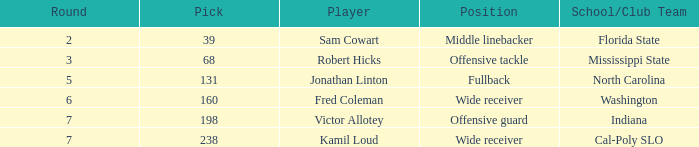Would you be able to parse every entry in this table? {'header': ['Round', 'Pick', 'Player', 'Position', 'School/Club Team'], 'rows': [['2', '39', 'Sam Cowart', 'Middle linebacker', 'Florida State'], ['3', '68', 'Robert Hicks', 'Offensive tackle', 'Mississippi State'], ['5', '131', 'Jonathan Linton', 'Fullback', 'North Carolina'], ['6', '160', 'Fred Coleman', 'Wide receiver', 'Washington'], ['7', '198', 'Victor Allotey', 'Offensive guard', 'Indiana'], ['7', '238', 'Kamil Loud', 'Wide receiver', 'Cal-Poly SLO']]} Which Round has a School/Club Team of cal-poly slo, and a Pick smaller than 238? None. 